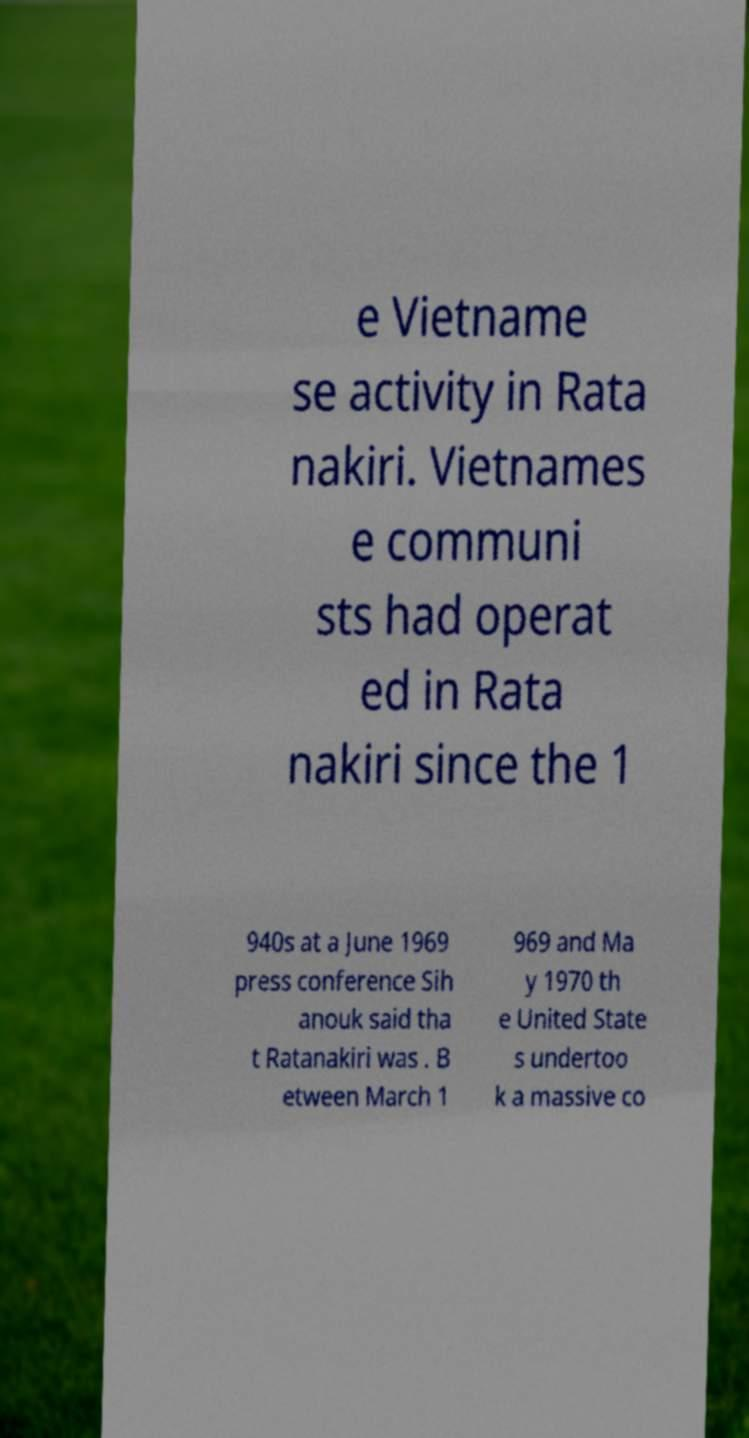Please identify and transcribe the text found in this image. e Vietname se activity in Rata nakiri. Vietnames e communi sts had operat ed in Rata nakiri since the 1 940s at a June 1969 press conference Sih anouk said tha t Ratanakiri was . B etween March 1 969 and Ma y 1970 th e United State s undertoo k a massive co 